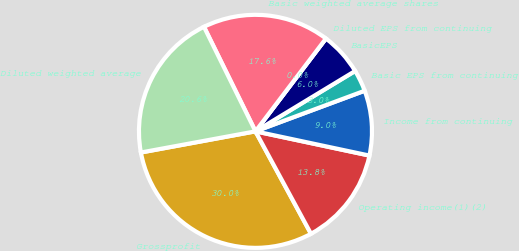Convert chart. <chart><loc_0><loc_0><loc_500><loc_500><pie_chart><fcel>Grossprofit<fcel>Operating income(1)(2)<fcel>Income from continuing<fcel>Basic EPS from continuing<fcel>BasicEPS<fcel>Diluted EPS from continuing<fcel>Basic weighted average shares<fcel>Diluted weighted average<nl><fcel>30.0%<fcel>13.76%<fcel>9.0%<fcel>3.0%<fcel>6.0%<fcel>0.0%<fcel>17.62%<fcel>20.62%<nl></chart> 